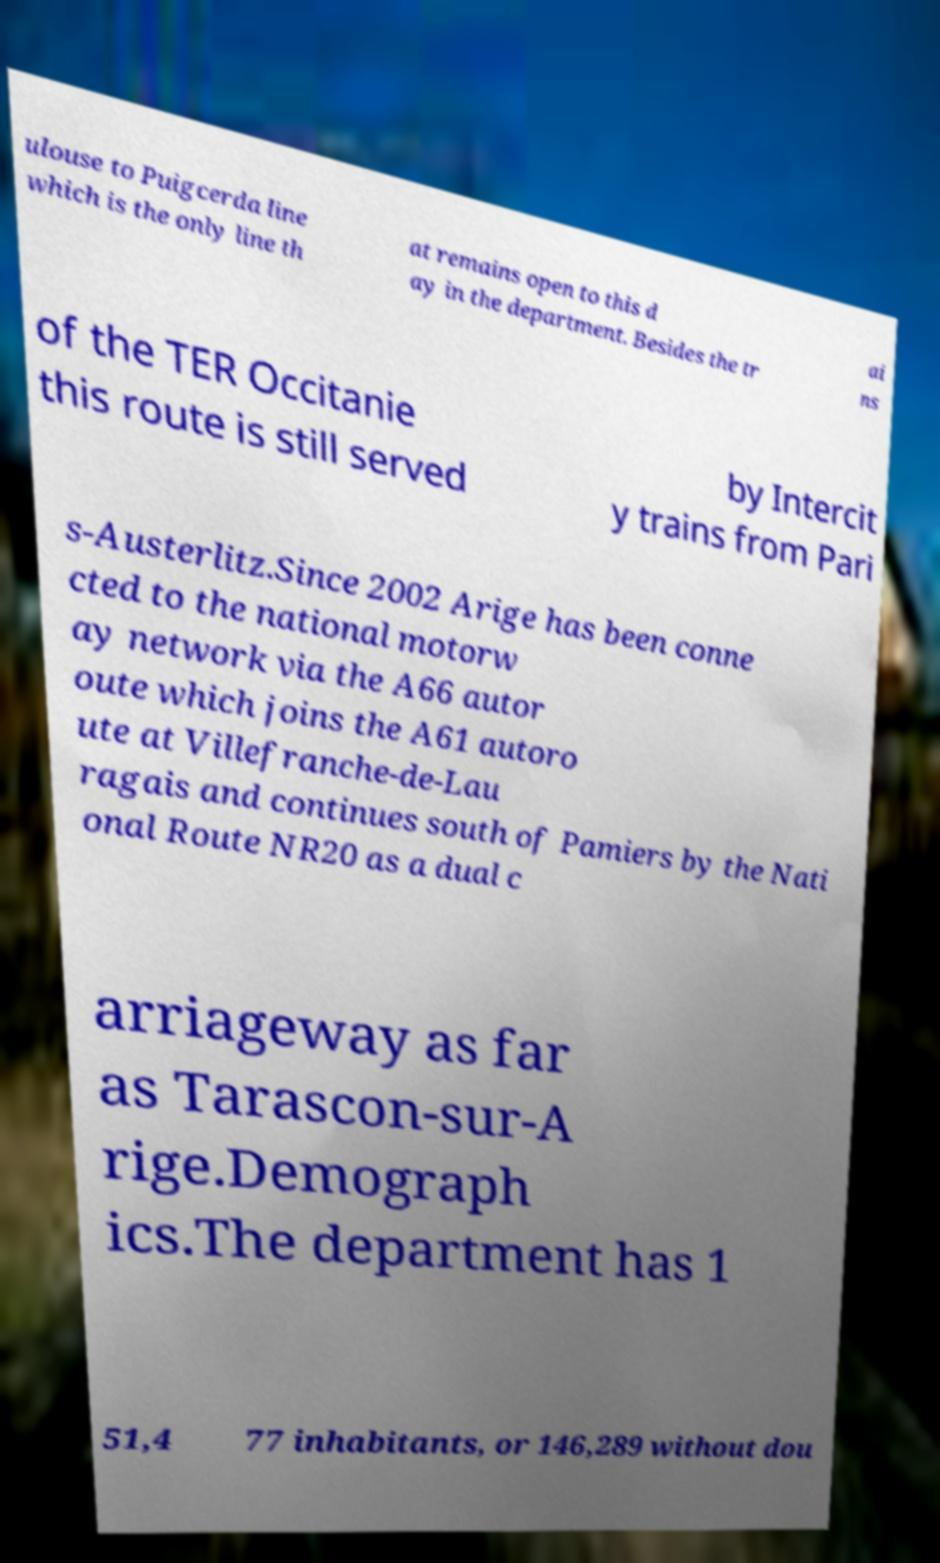There's text embedded in this image that I need extracted. Can you transcribe it verbatim? ulouse to Puigcerda line which is the only line th at remains open to this d ay in the department. Besides the tr ai ns of the TER Occitanie this route is still served by Intercit y trains from Pari s-Austerlitz.Since 2002 Arige has been conne cted to the national motorw ay network via the A66 autor oute which joins the A61 autoro ute at Villefranche-de-Lau ragais and continues south of Pamiers by the Nati onal Route NR20 as a dual c arriageway as far as Tarascon-sur-A rige.Demograph ics.The department has 1 51,4 77 inhabitants, or 146,289 without dou 